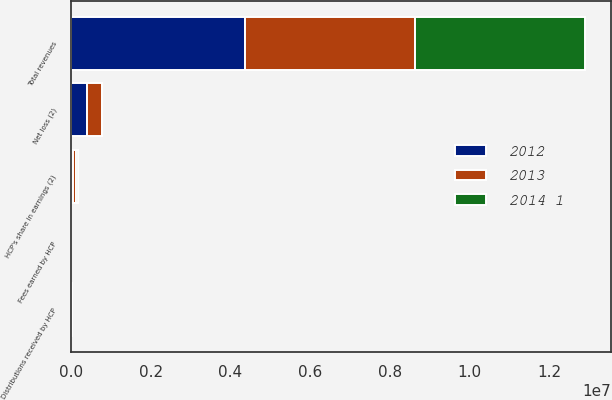Convert chart. <chart><loc_0><loc_0><loc_500><loc_500><stacked_bar_chart><ecel><fcel>Total revenues<fcel>Net loss (2)<fcel>HCP's share in earnings (2)<fcel>Fees earned by HCP<fcel>Distributions received by HCP<nl><fcel>2012<fcel>4.36382e+06<fcel>411385<fcel>49570<fcel>1809<fcel>7702<nl><fcel>2013<fcel>4.26916e+06<fcel>354079<fcel>64433<fcel>1847<fcel>18091<nl><fcel>2014 1<fcel>4.26032e+06<fcel>15865<fcel>54455<fcel>1895<fcel>6299<nl></chart> 